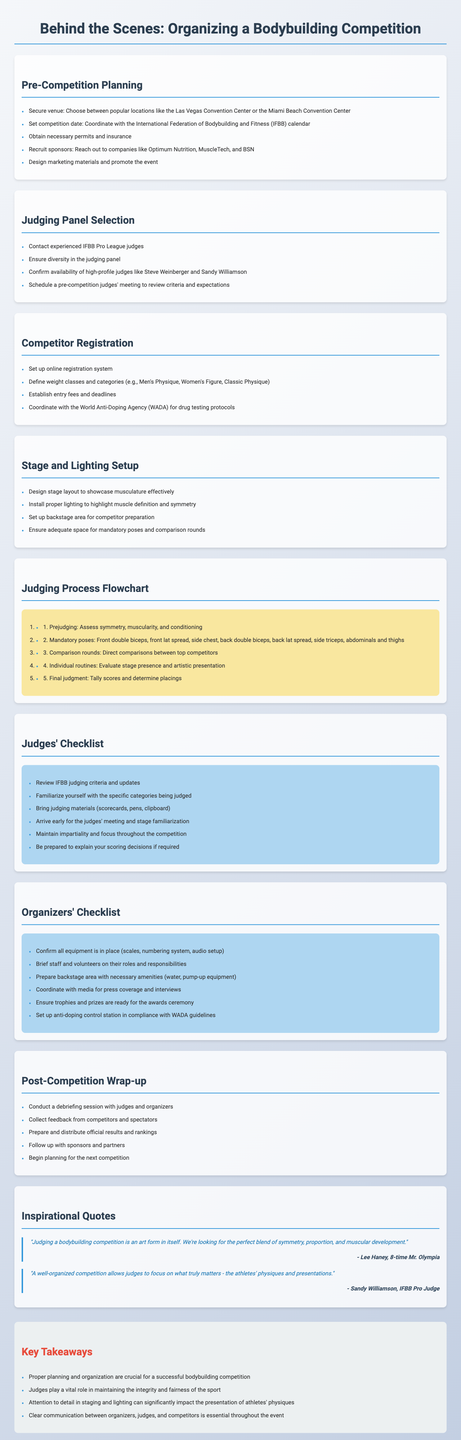What is the title of the document? The title is stated at the top of the brochure.
Answer: Behind the Scenes: Organizing a Bodybuilding Competition How many sections are in the document? The sections are listed throughout the document, including titles and content.
Answer: 8 What is one major company to recruit as a sponsor? This information is derived from the sponsors mentioned in the Pre-Competition Planning section.
Answer: Optimum Nutrition Who should be contacted for the judging panel selection? This information can be found under the Judging Panel Selection section.
Answer: Experienced IFBB Pro League judges What are the first two steps in the judging process flowchart? This information is detailed in the Judging Process Flowchart section of the document.
Answer: Prejudging and Mandatory poses What essential checklist item must judges bring? This information can be found in the Judges' Checklist section.
Answer: Judging materials What is a key takeaway regarding judges? The key takeaways summarize important aspects, including judges' roles.
Answer: Judges play a vital role in maintaining the integrity and fairness of the sport What is one of the last steps mentioned in the post-competition wrap-up? This information is found in the Post-Competition Wrap-up section.
Answer: Begin planning for the next competition 